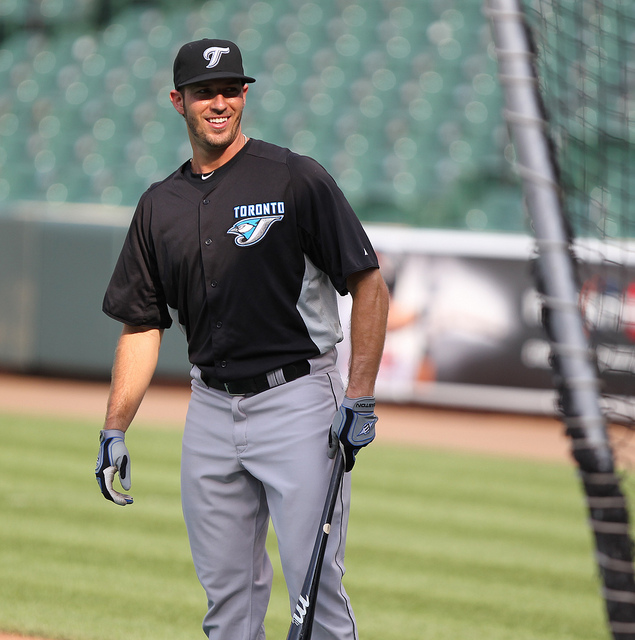<image>What is the team's mascot? I don't know what the team's mascot is. It could be a blue jay, a whale, or a falcon. What is the team's mascot? I don't know what the team's mascot is. It can be either 'blue jay', 'blue jays', 'whale', 'falcons' or 'not sure'. 